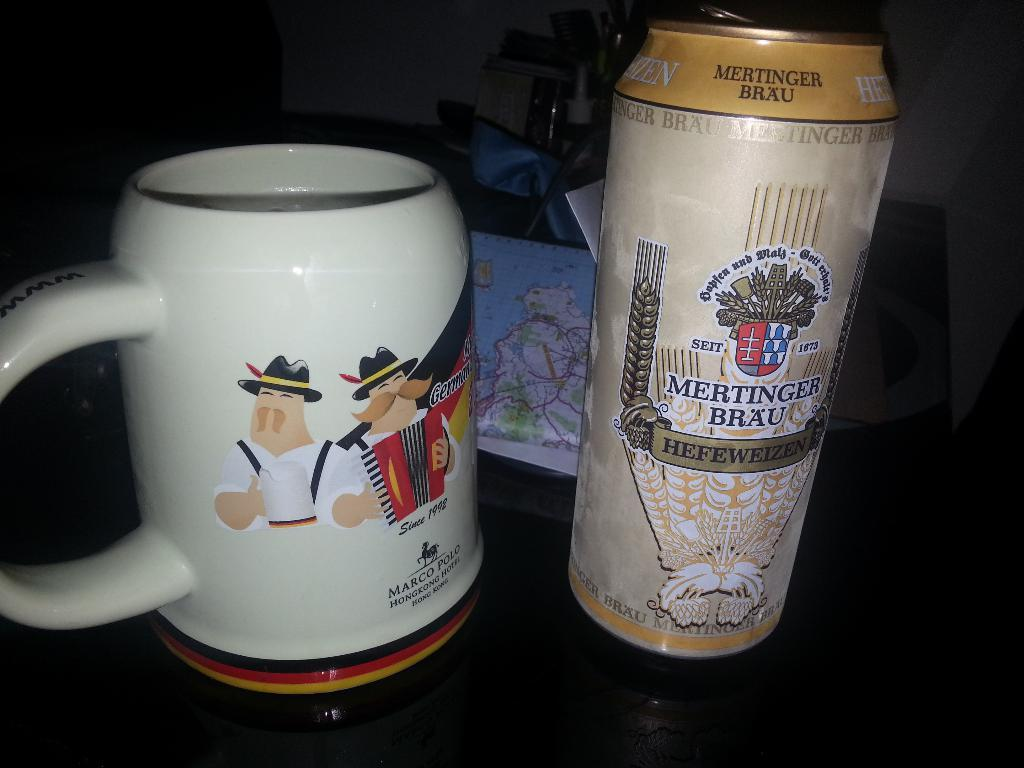<image>
Present a compact description of the photo's key features. A Marco Polo mug has two cartoon men on it. 